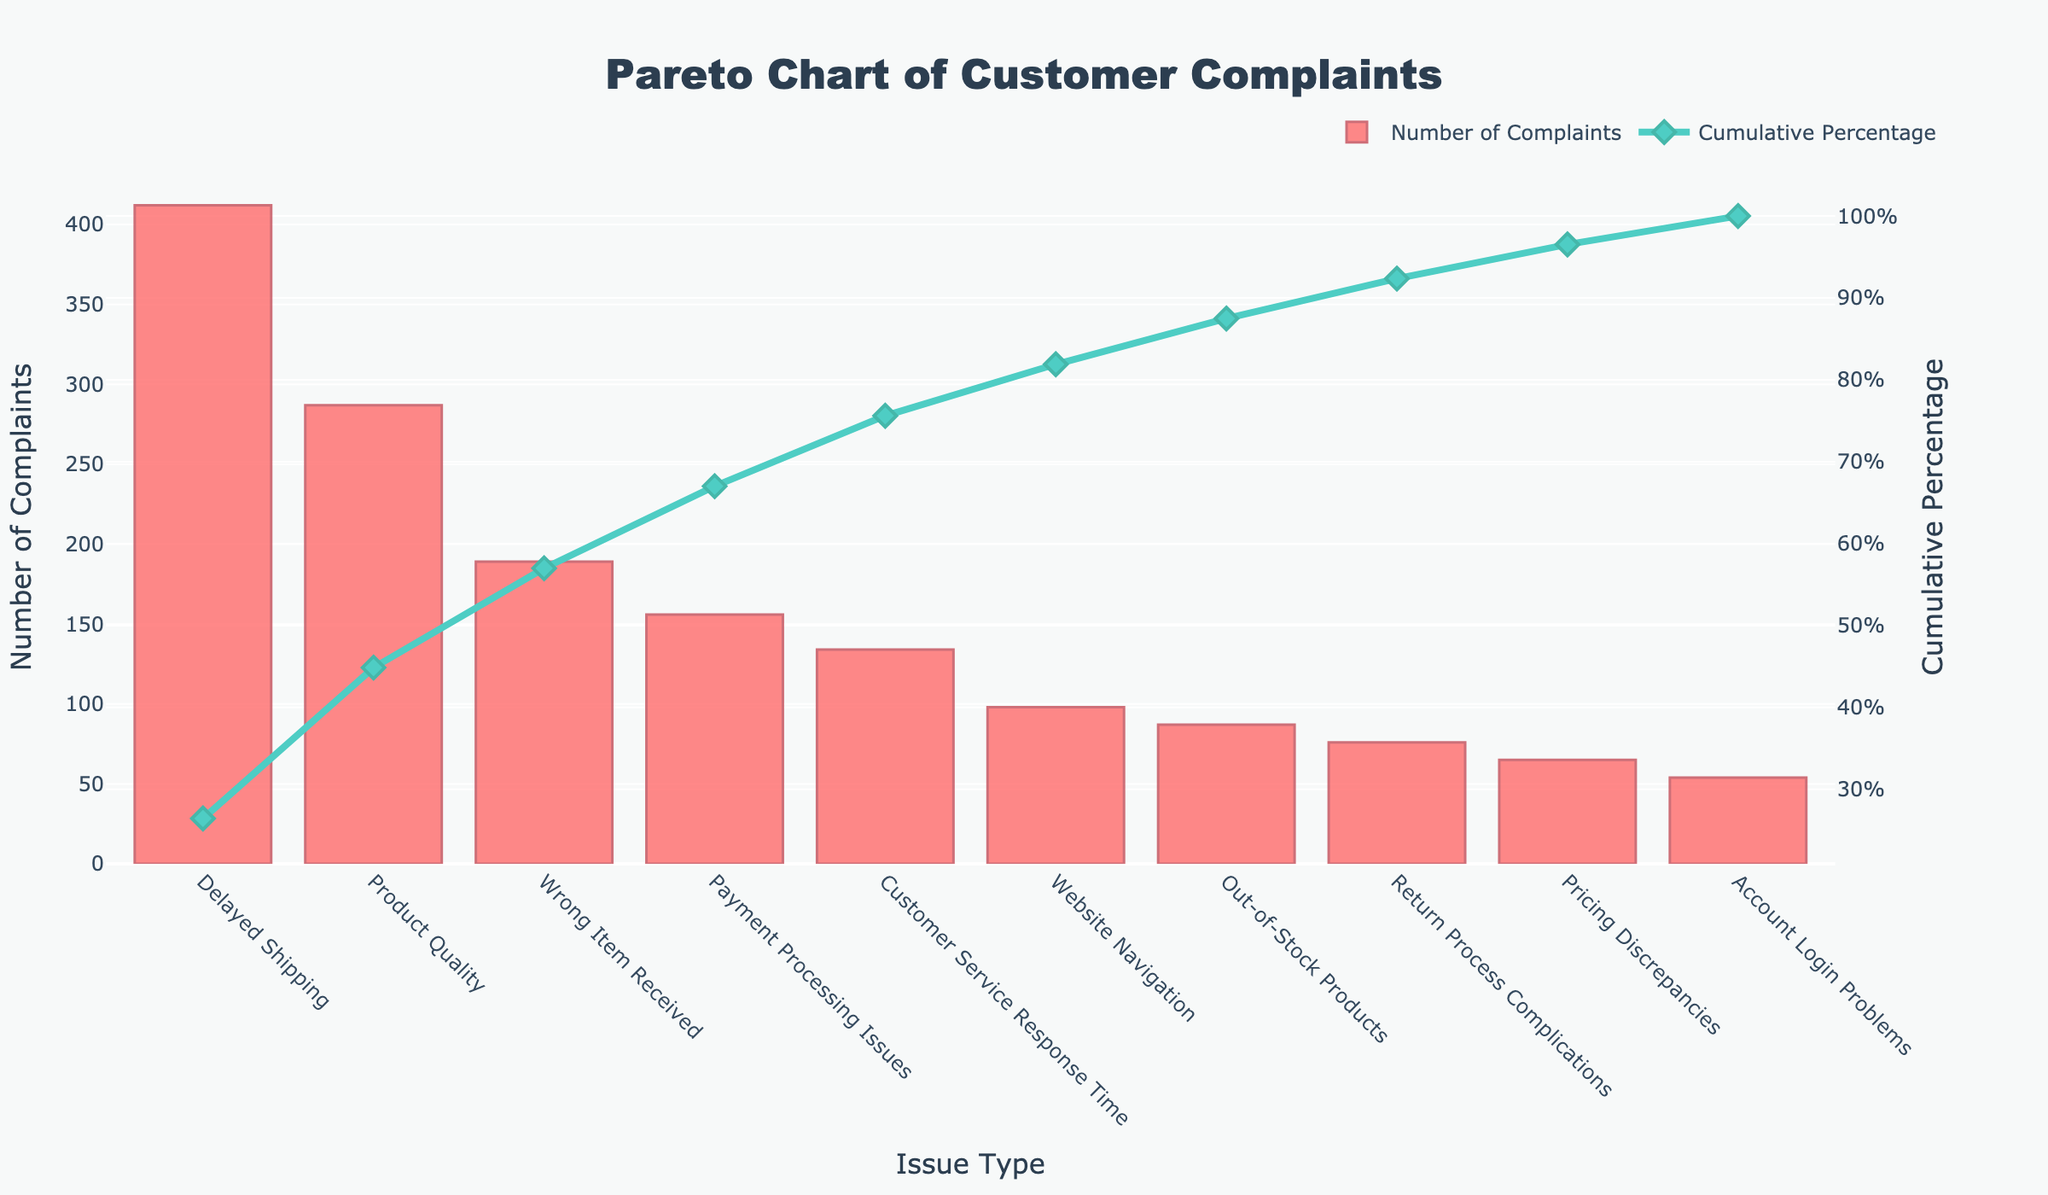What is the title of the Pareto chart? The title of the Pareto chart is displayed at the top of the figure.
Answer: Pareto Chart of Customer Complaints How many issue types are listed in the Pareto chart? Count the number of bars along the x-axis, each representing a different issue type.
Answer: 10 Which issue type has the highest number of complaints? Look at the bar with the highest value along the y-axis for 'Number of Complaints'.
Answer: Delayed Shipping What is the cumulative percentage after "Product Quality" issues? Refer to the cumulative percentage value displayed for the "Product Quality" issue on the secondary y-axis.
Answer: 50% Compare the number of complaints for "Wrong Item Received" and "Customer Service Response Time". Find the height of the bars corresponding to both "Wrong Item Received" and "Customer Service Response Time" along the primary y-axis, then compare their values.
Answer: Wrong Item Received has more complaints What is the combined number of complaints for "Payment Processing Issues" and "Out-of-Stock Products"? Add the number of complaints for "Payment Processing Issues" and "Out-of-Stock Products": 
156 (Payment Processing Issues) + 87 (Out-of-Stock Products).
Answer: 243 What is the cumulative percentage for "Pricing Discrepancies"? Locate "Pricing Discrepancies" on the x-axis and refer to its corresponding cumulative percentage on the secondary y-axis.
Answer: 96% How many total complaints are represented in the Pareto chart? Sum the values of all the bars representing the number of complaints.
Answer: 1558 What is the difference in the number of complaints between "Delayed Shipping" and "Website Navigation"? Subtract the number of complaints for "Website Navigation" from "Delayed Shipping": 
412 (Delayed Shipping) - 98 (Website Navigation).
Answer: 314 Is the cumulative percentage above 90% after "Return Process Complications"? Check the cumulative percentage value associated with "Return Process Complications" on the secondary y-axis and see if it exceeds 90%.
Answer: Yes 